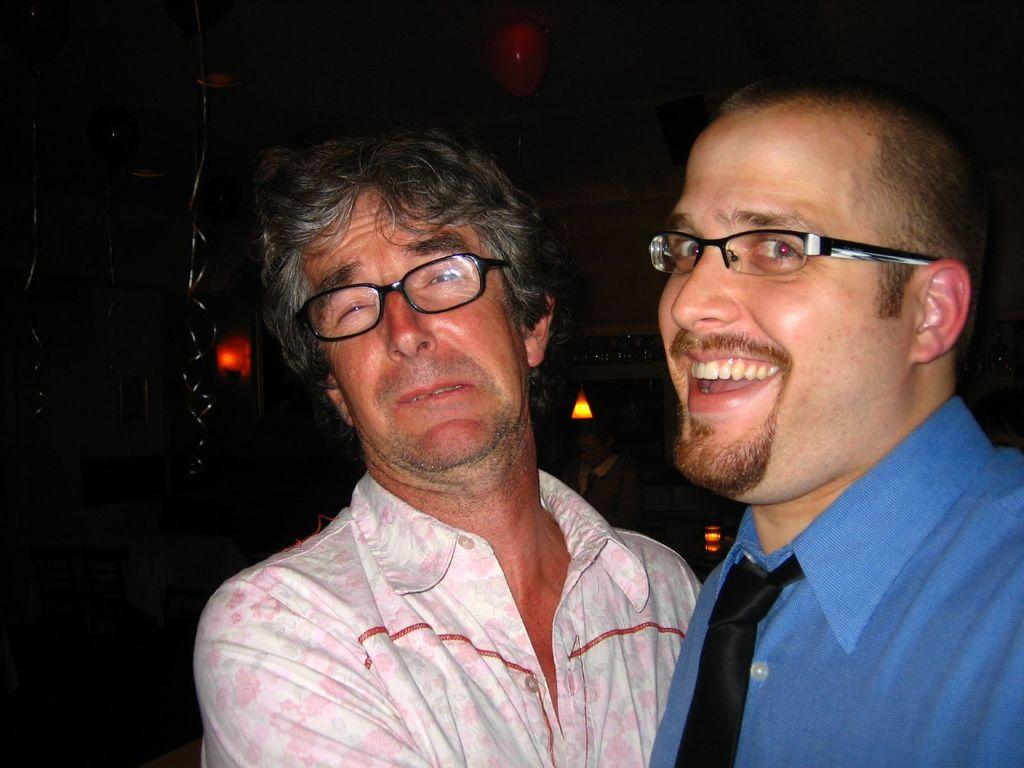How many men are in the image? There are two men in the image. What are the men doing in the image? The men are watching something. What are the men wearing in the image? The men are wearing glasses. What can be seen in the background of the image? There is a dark view, balloons, people, ribbons, lights, and other objects in the background of the image. Can you tell me how many cows are visible in the image? There are no cows present in the image. What direction are the pigs looking in the image? There are no pigs present in the image. 